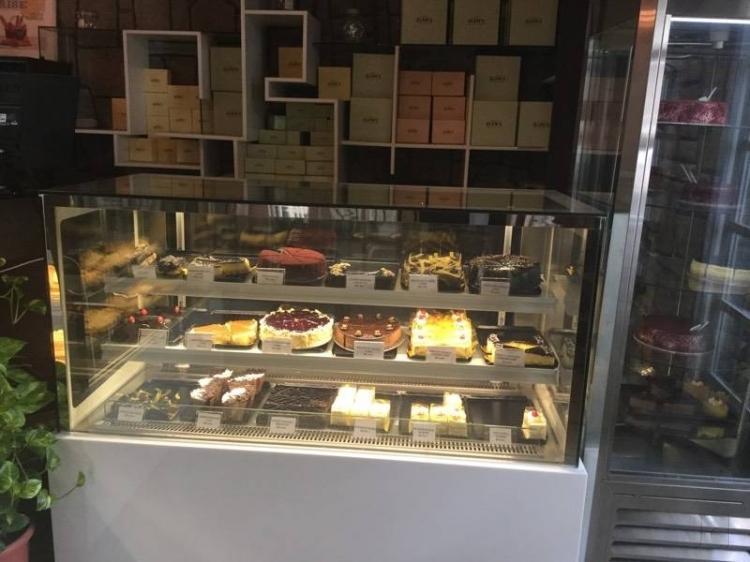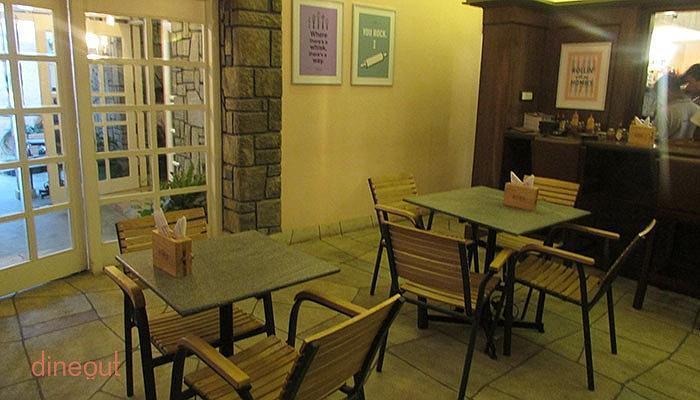The first image is the image on the left, the second image is the image on the right. For the images shown, is this caption "The right image shows round frosted cake-type desserts displayed on round glass shelves in a tall glass-fronted case." true? Answer yes or no. No. 